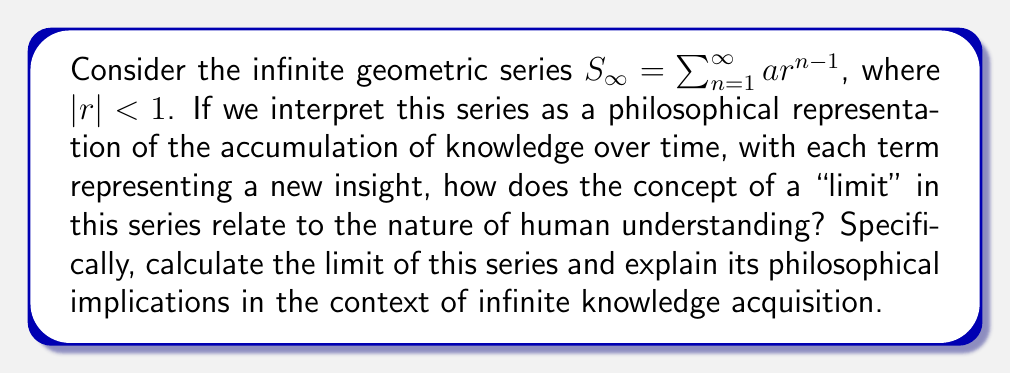Help me with this question. To approach this question, we need to consider both the mathematical and philosophical aspects:

1. Mathematical analysis:
The sum of an infinite geometric series is given by the formula:

$$S_{\infty} = \frac{a}{1-r}$$

where $a$ is the first term and $r$ is the common ratio, with $|r| < 1$.

This formula can be derived as follows:
Let $S_n$ be the sum of the first $n$ terms:

$$S_n = a + ar + ar^2 + ... + ar^{n-1}$$

Multiply both sides by $r$:

$$rS_n = ar + ar^2 + ... + ar^n$$

Subtract $rS_n$ from $S_n$:

$$S_n - rS_n = a - ar^n$$

Factor out $S_n$:

$$S_n(1-r) = a(1-r^n)$$

Solve for $S_n$:

$$S_n = \frac{a(1-r^n)}{1-r}$$

As $n$ approaches infinity, $r^n$ approaches 0 (since $|r| < 1$), giving us the final formula:

$$S_{\infty} = \lim_{n \to \infty} S_n = \frac{a}{1-r}$$

2. Philosophical interpretation:
The concept of a limit in this series can be interpreted as the ultimate extent of human understanding or knowledge acquisition. Each term in the series represents a new piece of knowledge or insight, with the sum approaching but never quite reaching a finite value (when $|r| < 1$).

This mathematical model suggests several philosophical implications:

a) Asymptotic nature of knowledge: The series approaches but never reaches its limit, much like how human understanding may approach but never fully attain absolute truth or complete knowledge.

b) Diminishing returns: Each subsequent term (ar^(n-1)) is smaller than the previous one, suggesting that new insights may become incrementally smaller or more difficult to obtain as knowledge accumulates.

c) Convergence of understanding: Despite the infinite number of terms, the series converges to a finite value, implying that there might be a theoretical "maximum" or "boundary" to human understanding, even if it's never fully reached.

d) The role of initial conditions: The values of $a$ and $r$ greatly influence the limit, suggesting that the starting point and rate of knowledge acquisition play crucial roles in determining the ultimate extent of understanding.

e) The importance of $|r| < 1$: This condition ensures convergence, philosophically implying that for knowledge to be meaningful and not chaotic, there must be some structure or diminishing pattern to how new insights build upon previous ones.
Answer: The limit of the infinite geometric series $S_{\infty} = \sum_{n=1}^{\infty} ar^{n-1}$, where $|r| < 1$, is given by:

$$S_{\infty} = \frac{a}{1-r}$$

This mathematical result suggests that while human knowledge and understanding can grow indefinitely, it may approach but never fully reach a theoretical maximum, reflecting the asymptotic nature of intellectual progress and the inherent limitations of human cognition. 